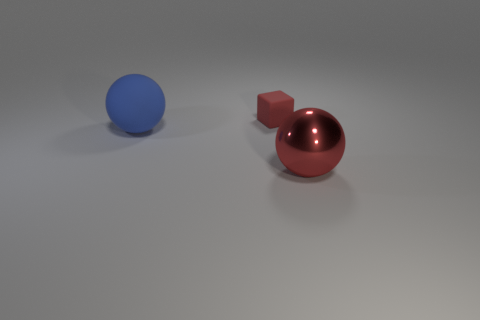Are there any other things that have the same material as the large red sphere?
Offer a very short reply. No. There is a thing that is the same color as the tiny rubber cube; what is its material?
Ensure brevity in your answer.  Metal. Is there any other thing that has the same shape as the big red metal thing?
Make the answer very short. Yes. There is a red object that is in front of the thing that is behind the matte sphere; what size is it?
Your response must be concise. Large. What number of large objects are either matte objects or cyan matte cylinders?
Your answer should be very brief. 1. Is the number of red spheres less than the number of tiny yellow rubber things?
Your answer should be very brief. No. Is there anything else that is the same size as the red rubber cube?
Ensure brevity in your answer.  No. Do the tiny matte block and the metallic ball have the same color?
Provide a succinct answer. Yes. Are there more large yellow balls than large matte things?
Your answer should be compact. No. How many other things are there of the same color as the big rubber thing?
Your answer should be very brief. 0. 